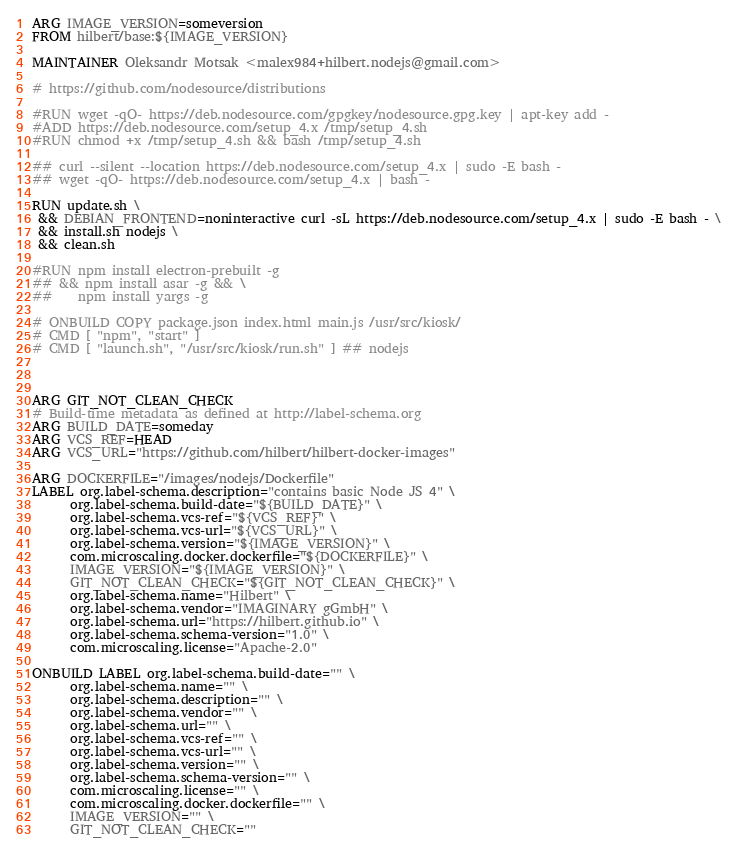Convert code to text. <code><loc_0><loc_0><loc_500><loc_500><_Dockerfile_>ARG IMAGE_VERSION=someversion
FROM hilbert/base:${IMAGE_VERSION}

MAINTAINER Oleksandr Motsak <malex984+hilbert.nodejs@gmail.com>

# https://github.com/nodesource/distributions

#RUN wget -qO- https://deb.nodesource.com/gpgkey/nodesource.gpg.key | apt-key add -
#ADD https://deb.nodesource.com/setup_4.x /tmp/setup_4.sh
#RUN chmod +x /tmp/setup_4.sh && bash /tmp/setup_4.sh

## curl --silent --location https://deb.nodesource.com/setup_4.x | sudo -E bash -
## wget -qO- https://deb.nodesource.com/setup_4.x | bash -

RUN update.sh \
 && DEBIAN_FRONTEND=noninteractive curl -sL https://deb.nodesource.com/setup_4.x | sudo -E bash - \
 && install.sh nodejs \
 && clean.sh

#RUN npm install electron-prebuilt -g 
## && npm install asar -g && \
##    npm install yargs -g

# ONBUILD COPY package.json index.html main.js /usr/src/kiosk/
# CMD [ "npm", "start" ]
# CMD [ "launch.sh", "/usr/src/kiosk/run.sh" ] ## nodejs



ARG GIT_NOT_CLEAN_CHECK
# Build-time metadata as defined at http://label-schema.org
ARG BUILD_DATE=someday
ARG VCS_REF=HEAD
ARG VCS_URL="https://github.com/hilbert/hilbert-docker-images"

ARG DOCKERFILE="/images/nodejs/Dockerfile"
LABEL org.label-schema.description="contains basic Node JS 4" \
      org.label-schema.build-date="${BUILD_DATE}" \
      org.label-schema.vcs-ref="${VCS_REF}" \
      org.label-schema.vcs-url="${VCS_URL}" \
      org.label-schema.version="${IMAGE_VERSION}" \
      com.microscaling.docker.dockerfile="${DOCKERFILE}" \
      IMAGE_VERSION="${IMAGE_VERSION}" \
      GIT_NOT_CLEAN_CHECK="${GIT_NOT_CLEAN_CHECK}" \
      org.label-schema.name="Hilbert" \
      org.label-schema.vendor="IMAGINARY gGmbH" \
      org.label-schema.url="https://hilbert.github.io" \
      org.label-schema.schema-version="1.0" \
      com.microscaling.license="Apache-2.0"     

ONBUILD LABEL org.label-schema.build-date="" \
      org.label-schema.name="" \
      org.label-schema.description="" \
      org.label-schema.vendor="" \
      org.label-schema.url="" \
      org.label-schema.vcs-ref="" \
      org.label-schema.vcs-url="" \
      org.label-schema.version="" \
      org.label-schema.schema-version="" \
      com.microscaling.license="" \
      com.microscaling.docker.dockerfile="" \
      IMAGE_VERSION="" \
      GIT_NOT_CLEAN_CHECK=""
</code> 